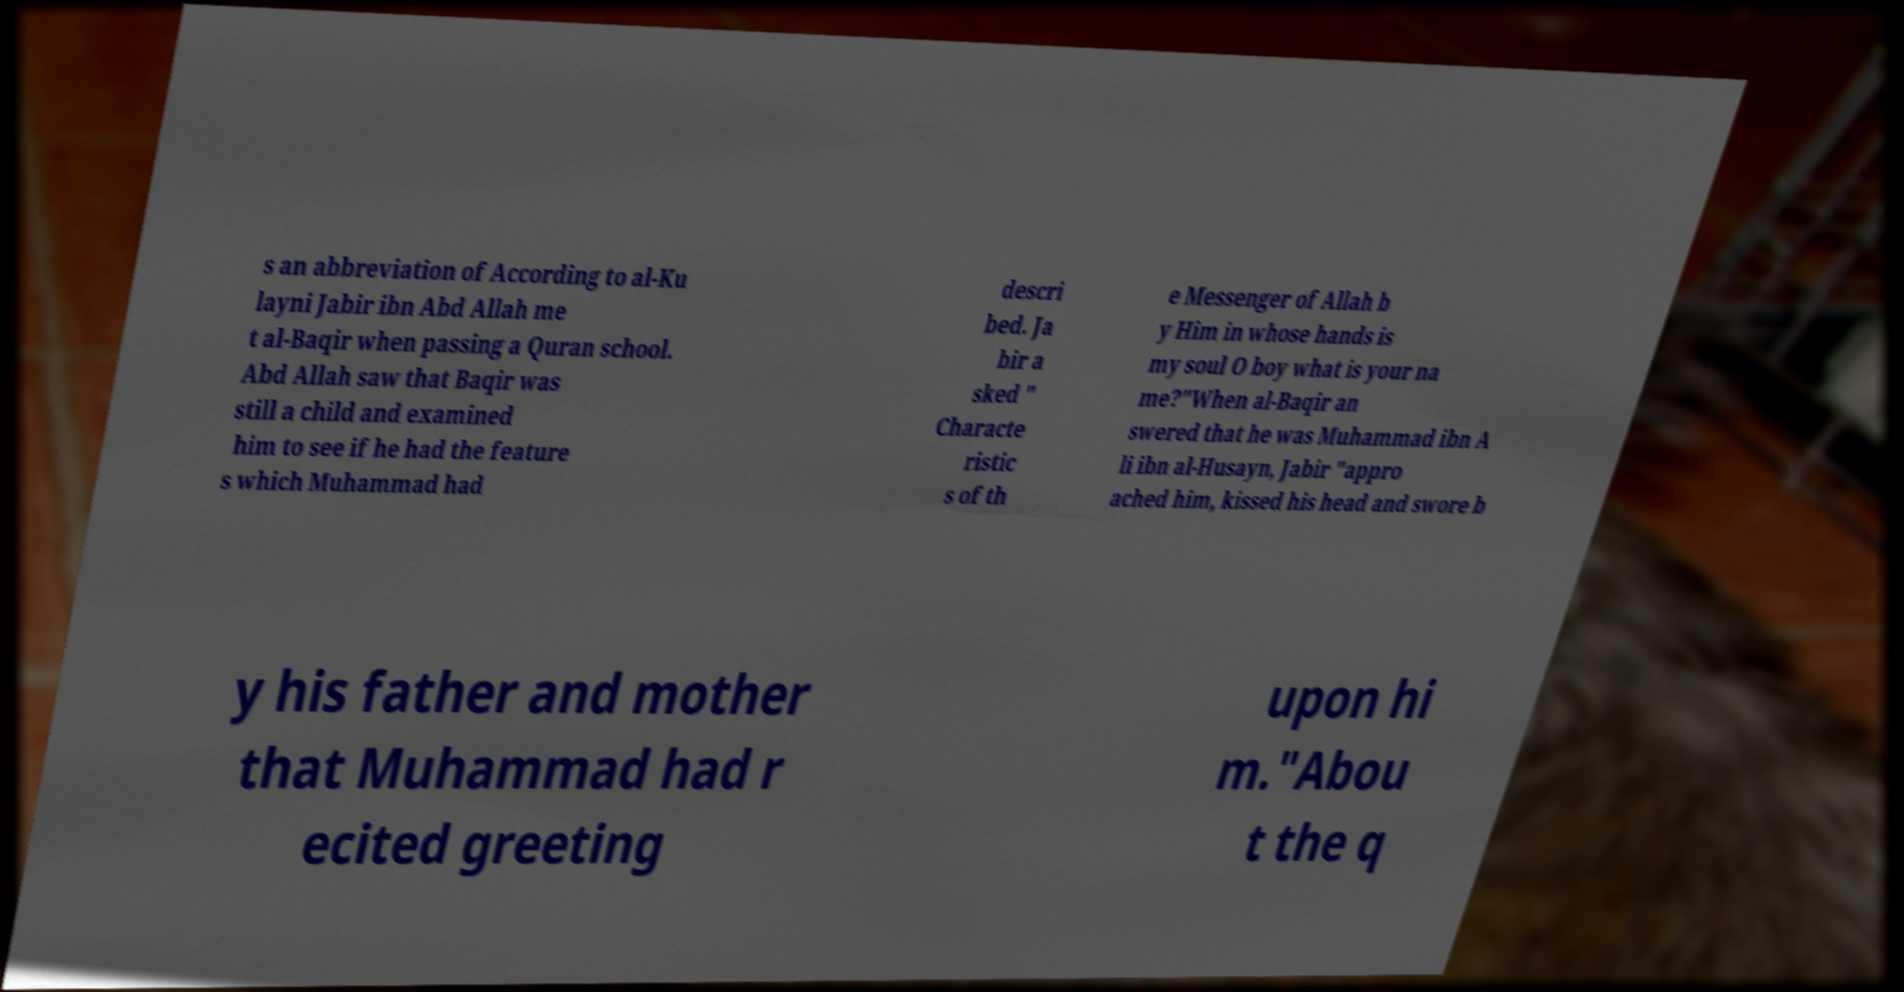Could you assist in decoding the text presented in this image and type it out clearly? s an abbreviation of According to al-Ku layni Jabir ibn Abd Allah me t al-Baqir when passing a Quran school. Abd Allah saw that Baqir was still a child and examined him to see if he had the feature s which Muhammad had descri bed. Ja bir a sked " Characte ristic s of th e Messenger of Allah b y Him in whose hands is my soul O boy what is your na me?"When al-Baqir an swered that he was Muhammad ibn A li ibn al-Husayn, Jabir "appro ached him, kissed his head and swore b y his father and mother that Muhammad had r ecited greeting upon hi m."Abou t the q 